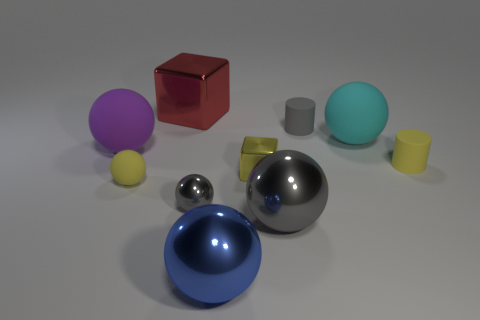Does the tiny sphere on the left side of the big red shiny cube have the same color as the tiny object that is right of the small gray matte thing?
Offer a very short reply. Yes. The other metallic sphere that is the same color as the tiny metallic ball is what size?
Offer a terse response. Large. Are the large blue thing in front of the large cyan object and the big cyan sphere made of the same material?
Ensure brevity in your answer.  No. Is the color of the tiny thing that is right of the gray matte cylinder the same as the small matte sphere?
Your answer should be very brief. Yes. What is the size of the blue shiny thing that is the same shape as the large cyan rubber object?
Keep it short and to the point. Large. Is the size of the yellow metal object the same as the yellow rubber ball?
Provide a succinct answer. Yes. What color is the other big shiny object that is the same shape as the big gray thing?
Your answer should be compact. Blue. What number of tiny cylinders have the same color as the tiny metallic sphere?
Keep it short and to the point. 1. Are there more big red shiny objects to the left of the yellow rubber cylinder than big yellow shiny spheres?
Your answer should be compact. Yes. What is the color of the tiny cylinder in front of the large rubber ball behind the purple thing?
Your response must be concise. Yellow. 